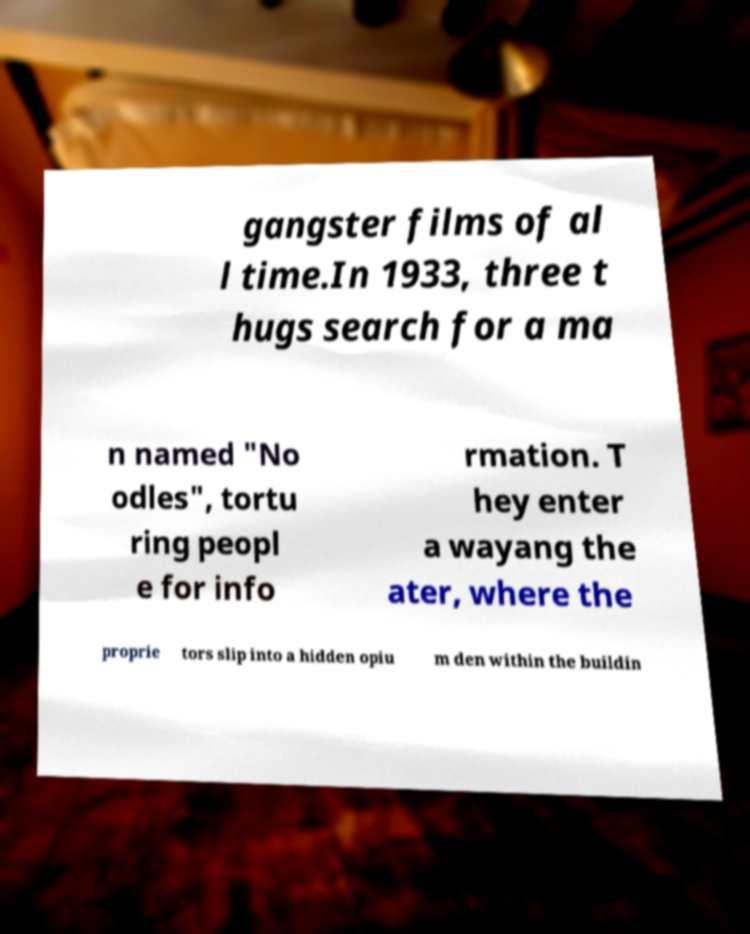Could you extract and type out the text from this image? gangster films of al l time.In 1933, three t hugs search for a ma n named "No odles", tortu ring peopl e for info rmation. T hey enter a wayang the ater, where the proprie tors slip into a hidden opiu m den within the buildin 